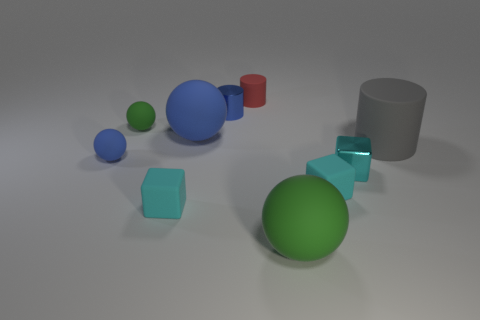Is the size of the cyan metal object the same as the cyan matte cube to the right of the tiny blue shiny cylinder?
Your answer should be very brief. Yes. What number of balls are small red matte things or large matte objects?
Offer a very short reply. 2. There is a red object that is the same material as the large gray cylinder; what size is it?
Make the answer very short. Small. There is a blue rubber sphere that is on the left side of the big blue object; does it have the same size as the green object left of the tiny matte cylinder?
Provide a succinct answer. Yes. How many things are either red cylinders or gray matte things?
Provide a short and direct response. 2. What is the shape of the tiny green matte thing?
Your answer should be very brief. Sphere. The other green rubber object that is the same shape as the large green rubber object is what size?
Your answer should be very brief. Small. Is there anything else that is the same material as the large gray cylinder?
Provide a succinct answer. Yes. There is a green object behind the metal thing that is in front of the tiny blue cylinder; how big is it?
Provide a succinct answer. Small. Are there an equal number of big green things that are behind the gray thing and tiny red matte cylinders?
Offer a very short reply. No. 